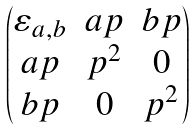Convert formula to latex. <formula><loc_0><loc_0><loc_500><loc_500>\begin{pmatrix} \varepsilon _ { a , b } & a p & b p \\ a p & p ^ { 2 } & 0 \\ b p & 0 & p ^ { 2 } \end{pmatrix}</formula> 